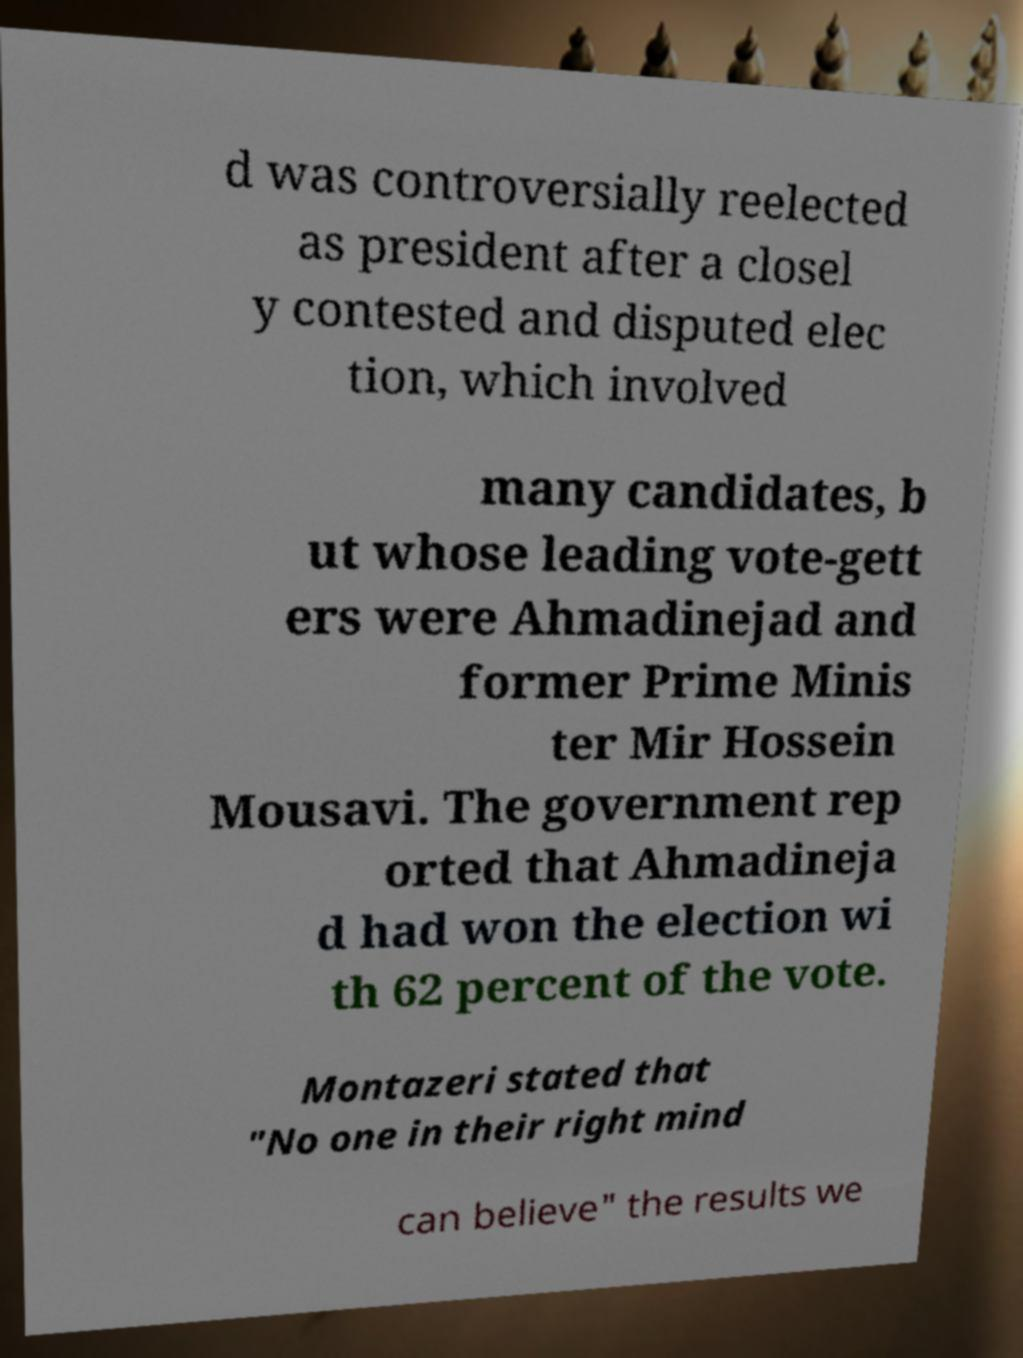Please identify and transcribe the text found in this image. d was controversially reelected as president after a closel y contested and disputed elec tion, which involved many candidates, b ut whose leading vote-gett ers were Ahmadinejad and former Prime Minis ter Mir Hossein Mousavi. The government rep orted that Ahmadineja d had won the election wi th 62 percent of the vote. Montazeri stated that "No one in their right mind can believe" the results we 